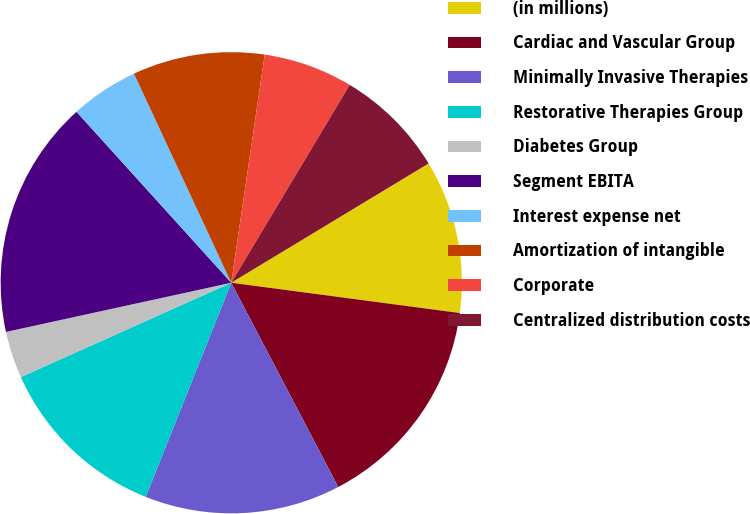Convert chart to OTSL. <chart><loc_0><loc_0><loc_500><loc_500><pie_chart><fcel>(in millions)<fcel>Cardiac and Vascular Group<fcel>Minimally Invasive Therapies<fcel>Restorative Therapies Group<fcel>Diabetes Group<fcel>Segment EBITA<fcel>Interest expense net<fcel>Amortization of intangible<fcel>Corporate<fcel>Centralized distribution costs<nl><fcel>10.75%<fcel>15.22%<fcel>13.73%<fcel>12.24%<fcel>3.29%<fcel>16.71%<fcel>4.78%<fcel>9.25%<fcel>6.27%<fcel>7.76%<nl></chart> 